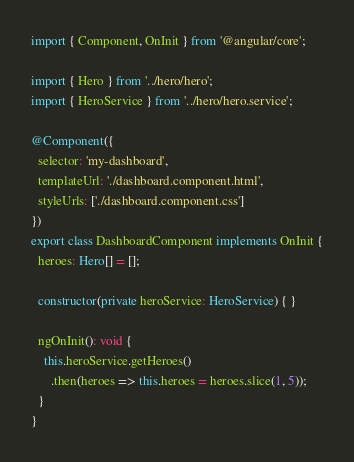Convert code to text. <code><loc_0><loc_0><loc_500><loc_500><_TypeScript_>import { Component, OnInit } from '@angular/core';

import { Hero } from '../hero/hero';
import { HeroService } from '../hero/hero.service';

@Component({
  selector: 'my-dashboard',
  templateUrl: './dashboard.component.html',
  styleUrls: ['./dashboard.component.css']
})
export class DashboardComponent implements OnInit {
  heroes: Hero[] = [];

  constructor(private heroService: HeroService) { }

  ngOnInit(): void {
    this.heroService.getHeroes()
      .then(heroes => this.heroes = heroes.slice(1, 5));
  }
}
</code> 